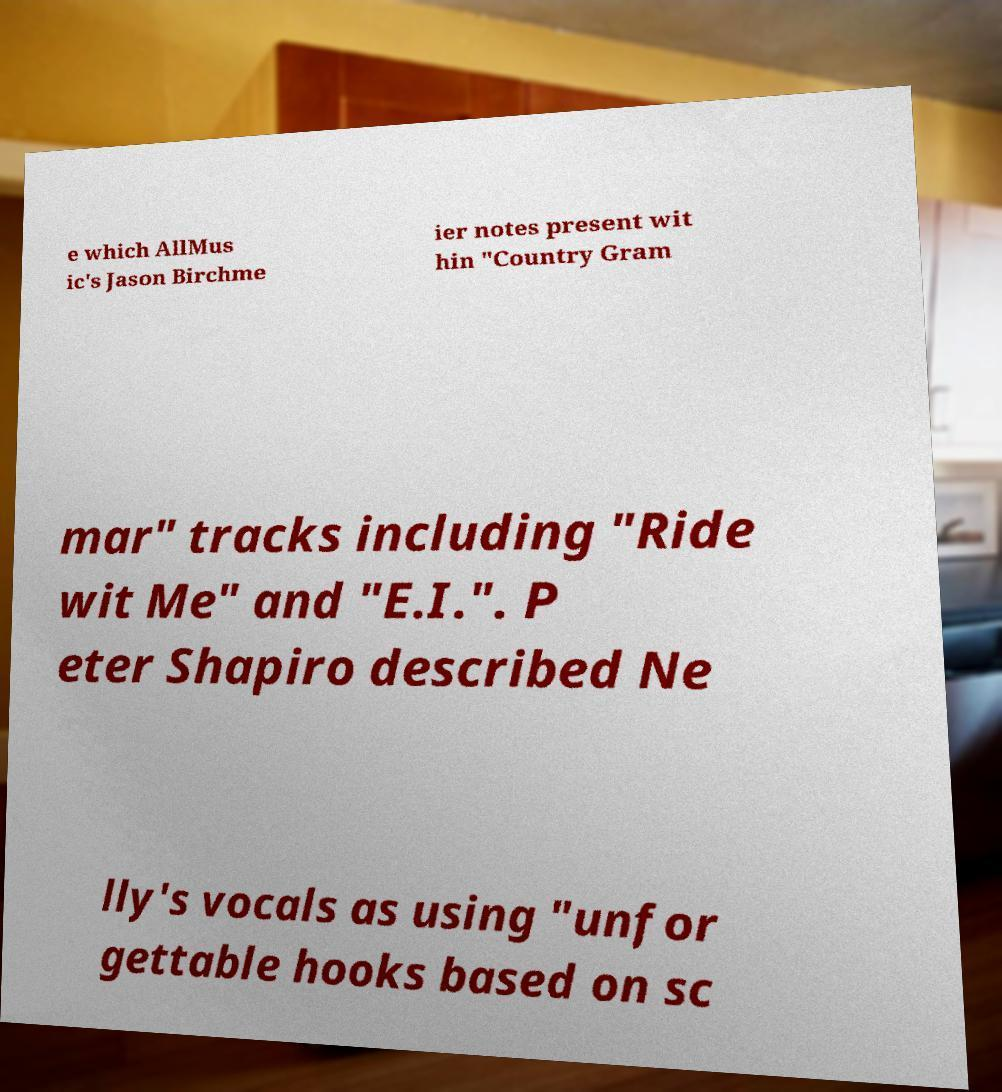For documentation purposes, I need the text within this image transcribed. Could you provide that? e which AllMus ic's Jason Birchme ier notes present wit hin "Country Gram mar" tracks including "Ride wit Me" and "E.I.". P eter Shapiro described Ne lly's vocals as using "unfor gettable hooks based on sc 